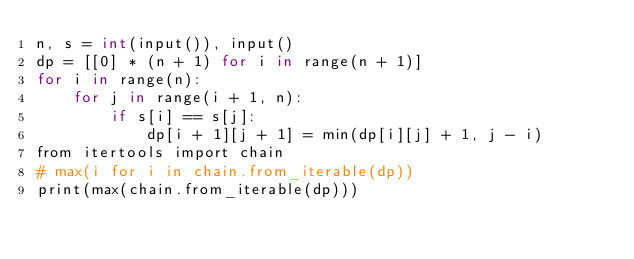Convert code to text. <code><loc_0><loc_0><loc_500><loc_500><_Cython_>n, s = int(input()), input()
dp = [[0] * (n + 1) for i in range(n + 1)]
for i in range(n):
    for j in range(i + 1, n):
        if s[i] == s[j]:
            dp[i + 1][j + 1] = min(dp[i][j] + 1, j - i)
from itertools import chain
# max(i for i in chain.from_iterable(dp))
print(max(chain.from_iterable(dp)))
</code> 